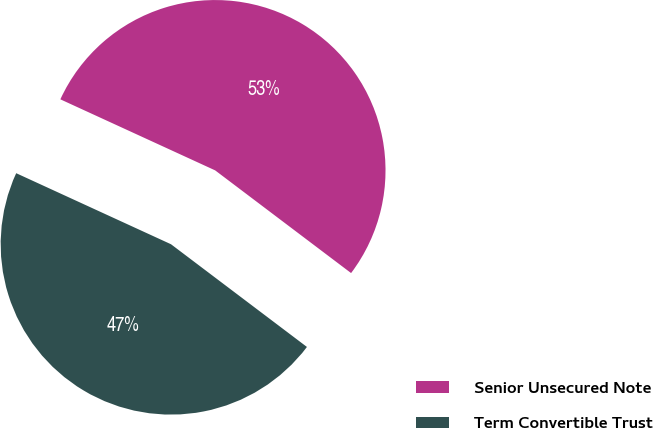<chart> <loc_0><loc_0><loc_500><loc_500><pie_chart><fcel>Senior Unsecured Note<fcel>Term Convertible Trust<nl><fcel>53.45%<fcel>46.55%<nl></chart> 